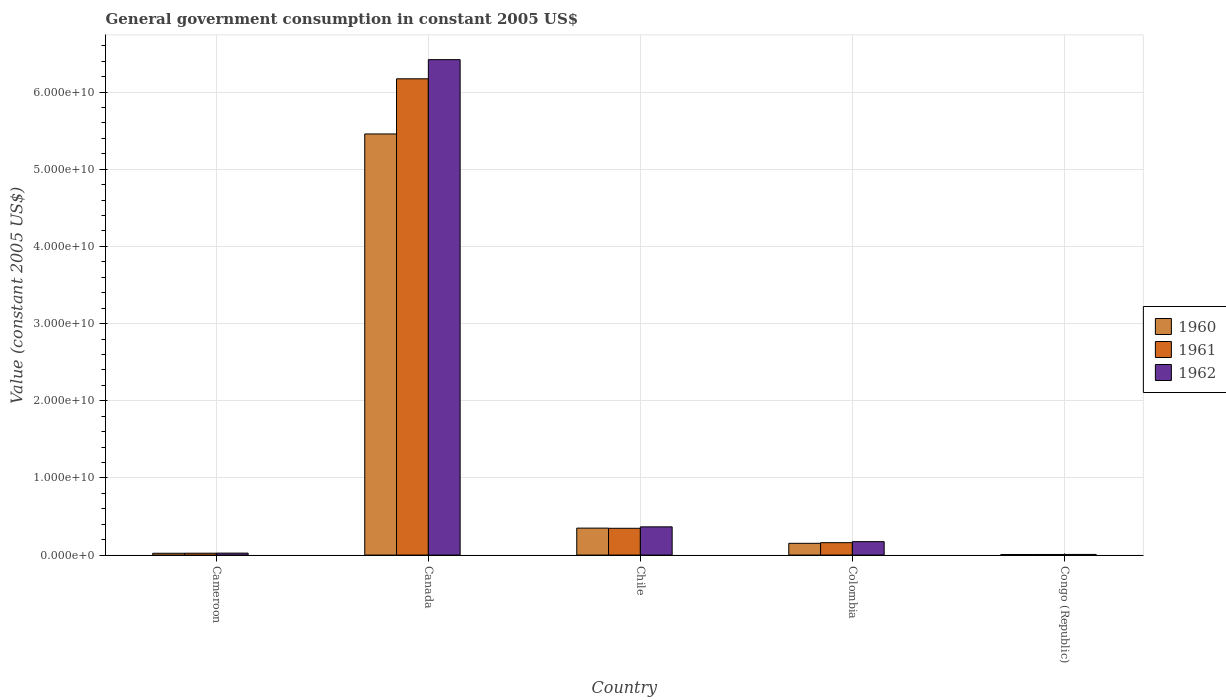How many different coloured bars are there?
Make the answer very short. 3. Are the number of bars per tick equal to the number of legend labels?
Make the answer very short. Yes. How many bars are there on the 5th tick from the left?
Your answer should be compact. 3. How many bars are there on the 5th tick from the right?
Give a very brief answer. 3. In how many cases, is the number of bars for a given country not equal to the number of legend labels?
Your response must be concise. 0. What is the government conusmption in 1960 in Congo (Republic)?
Your answer should be very brief. 7.44e+07. Across all countries, what is the maximum government conusmption in 1962?
Your response must be concise. 6.42e+1. Across all countries, what is the minimum government conusmption in 1962?
Give a very brief answer. 8.33e+07. In which country was the government conusmption in 1960 maximum?
Provide a short and direct response. Canada. In which country was the government conusmption in 1960 minimum?
Give a very brief answer. Congo (Republic). What is the total government conusmption in 1960 in the graph?
Provide a short and direct response. 5.99e+1. What is the difference between the government conusmption in 1960 in Chile and that in Congo (Republic)?
Make the answer very short. 3.42e+09. What is the difference between the government conusmption in 1962 in Cameroon and the government conusmption in 1961 in Canada?
Keep it short and to the point. -6.15e+1. What is the average government conusmption in 1960 per country?
Your answer should be compact. 1.20e+1. What is the difference between the government conusmption of/in 1961 and government conusmption of/in 1962 in Canada?
Offer a very short reply. -2.48e+09. What is the ratio of the government conusmption in 1960 in Cameroon to that in Colombia?
Offer a very short reply. 0.15. Is the difference between the government conusmption in 1961 in Canada and Congo (Republic) greater than the difference between the government conusmption in 1962 in Canada and Congo (Republic)?
Provide a short and direct response. No. What is the difference between the highest and the second highest government conusmption in 1961?
Make the answer very short. -1.86e+09. What is the difference between the highest and the lowest government conusmption in 1960?
Make the answer very short. 5.45e+1. Is the sum of the government conusmption in 1960 in Chile and Colombia greater than the maximum government conusmption in 1961 across all countries?
Ensure brevity in your answer.  No. What does the 1st bar from the left in Chile represents?
Provide a succinct answer. 1960. What does the 1st bar from the right in Congo (Republic) represents?
Provide a short and direct response. 1962. How many countries are there in the graph?
Your response must be concise. 5. What is the difference between two consecutive major ticks on the Y-axis?
Ensure brevity in your answer.  1.00e+1. Where does the legend appear in the graph?
Your response must be concise. Center right. How are the legend labels stacked?
Provide a succinct answer. Vertical. What is the title of the graph?
Offer a terse response. General government consumption in constant 2005 US$. What is the label or title of the Y-axis?
Keep it short and to the point. Value (constant 2005 US$). What is the Value (constant 2005 US$) in 1960 in Cameroon?
Provide a succinct answer. 2.33e+08. What is the Value (constant 2005 US$) in 1961 in Cameroon?
Your answer should be very brief. 2.41e+08. What is the Value (constant 2005 US$) in 1962 in Cameroon?
Give a very brief answer. 2.54e+08. What is the Value (constant 2005 US$) of 1960 in Canada?
Make the answer very short. 5.46e+1. What is the Value (constant 2005 US$) in 1961 in Canada?
Offer a very short reply. 6.17e+1. What is the Value (constant 2005 US$) in 1962 in Canada?
Your answer should be compact. 6.42e+1. What is the Value (constant 2005 US$) in 1960 in Chile?
Provide a succinct answer. 3.49e+09. What is the Value (constant 2005 US$) of 1961 in Chile?
Keep it short and to the point. 3.47e+09. What is the Value (constant 2005 US$) of 1962 in Chile?
Offer a very short reply. 3.66e+09. What is the Value (constant 2005 US$) of 1960 in Colombia?
Offer a terse response. 1.52e+09. What is the Value (constant 2005 US$) in 1961 in Colombia?
Your answer should be very brief. 1.61e+09. What is the Value (constant 2005 US$) in 1962 in Colombia?
Provide a succinct answer. 1.74e+09. What is the Value (constant 2005 US$) in 1960 in Congo (Republic)?
Offer a very short reply. 7.44e+07. What is the Value (constant 2005 US$) of 1961 in Congo (Republic)?
Your answer should be very brief. 7.67e+07. What is the Value (constant 2005 US$) in 1962 in Congo (Republic)?
Keep it short and to the point. 8.33e+07. Across all countries, what is the maximum Value (constant 2005 US$) in 1960?
Your response must be concise. 5.46e+1. Across all countries, what is the maximum Value (constant 2005 US$) in 1961?
Keep it short and to the point. 6.17e+1. Across all countries, what is the maximum Value (constant 2005 US$) of 1962?
Offer a very short reply. 6.42e+1. Across all countries, what is the minimum Value (constant 2005 US$) in 1960?
Offer a very short reply. 7.44e+07. Across all countries, what is the minimum Value (constant 2005 US$) of 1961?
Offer a very short reply. 7.67e+07. Across all countries, what is the minimum Value (constant 2005 US$) of 1962?
Make the answer very short. 8.33e+07. What is the total Value (constant 2005 US$) in 1960 in the graph?
Offer a very short reply. 5.99e+1. What is the total Value (constant 2005 US$) in 1961 in the graph?
Give a very brief answer. 6.71e+1. What is the total Value (constant 2005 US$) of 1962 in the graph?
Your answer should be very brief. 6.99e+1. What is the difference between the Value (constant 2005 US$) in 1960 in Cameroon and that in Canada?
Provide a succinct answer. -5.43e+1. What is the difference between the Value (constant 2005 US$) of 1961 in Cameroon and that in Canada?
Offer a terse response. -6.15e+1. What is the difference between the Value (constant 2005 US$) of 1962 in Cameroon and that in Canada?
Your answer should be compact. -6.40e+1. What is the difference between the Value (constant 2005 US$) in 1960 in Cameroon and that in Chile?
Offer a very short reply. -3.26e+09. What is the difference between the Value (constant 2005 US$) in 1961 in Cameroon and that in Chile?
Ensure brevity in your answer.  -3.23e+09. What is the difference between the Value (constant 2005 US$) of 1962 in Cameroon and that in Chile?
Make the answer very short. -3.40e+09. What is the difference between the Value (constant 2005 US$) in 1960 in Cameroon and that in Colombia?
Keep it short and to the point. -1.29e+09. What is the difference between the Value (constant 2005 US$) of 1961 in Cameroon and that in Colombia?
Your answer should be very brief. -1.37e+09. What is the difference between the Value (constant 2005 US$) of 1962 in Cameroon and that in Colombia?
Your response must be concise. -1.49e+09. What is the difference between the Value (constant 2005 US$) of 1960 in Cameroon and that in Congo (Republic)?
Ensure brevity in your answer.  1.59e+08. What is the difference between the Value (constant 2005 US$) in 1961 in Cameroon and that in Congo (Republic)?
Ensure brevity in your answer.  1.64e+08. What is the difference between the Value (constant 2005 US$) in 1962 in Cameroon and that in Congo (Republic)?
Your answer should be compact. 1.70e+08. What is the difference between the Value (constant 2005 US$) in 1960 in Canada and that in Chile?
Your response must be concise. 5.11e+1. What is the difference between the Value (constant 2005 US$) in 1961 in Canada and that in Chile?
Ensure brevity in your answer.  5.83e+1. What is the difference between the Value (constant 2005 US$) of 1962 in Canada and that in Chile?
Your answer should be compact. 6.05e+1. What is the difference between the Value (constant 2005 US$) in 1960 in Canada and that in Colombia?
Provide a short and direct response. 5.31e+1. What is the difference between the Value (constant 2005 US$) of 1961 in Canada and that in Colombia?
Your response must be concise. 6.01e+1. What is the difference between the Value (constant 2005 US$) in 1962 in Canada and that in Colombia?
Keep it short and to the point. 6.25e+1. What is the difference between the Value (constant 2005 US$) of 1960 in Canada and that in Congo (Republic)?
Provide a succinct answer. 5.45e+1. What is the difference between the Value (constant 2005 US$) of 1961 in Canada and that in Congo (Republic)?
Offer a terse response. 6.16e+1. What is the difference between the Value (constant 2005 US$) of 1962 in Canada and that in Congo (Republic)?
Your response must be concise. 6.41e+1. What is the difference between the Value (constant 2005 US$) in 1960 in Chile and that in Colombia?
Provide a short and direct response. 1.97e+09. What is the difference between the Value (constant 2005 US$) in 1961 in Chile and that in Colombia?
Offer a terse response. 1.86e+09. What is the difference between the Value (constant 2005 US$) of 1962 in Chile and that in Colombia?
Give a very brief answer. 1.92e+09. What is the difference between the Value (constant 2005 US$) of 1960 in Chile and that in Congo (Republic)?
Offer a terse response. 3.42e+09. What is the difference between the Value (constant 2005 US$) in 1961 in Chile and that in Congo (Republic)?
Your answer should be very brief. 3.39e+09. What is the difference between the Value (constant 2005 US$) of 1962 in Chile and that in Congo (Republic)?
Ensure brevity in your answer.  3.57e+09. What is the difference between the Value (constant 2005 US$) of 1960 in Colombia and that in Congo (Republic)?
Ensure brevity in your answer.  1.45e+09. What is the difference between the Value (constant 2005 US$) of 1961 in Colombia and that in Congo (Republic)?
Provide a succinct answer. 1.53e+09. What is the difference between the Value (constant 2005 US$) of 1962 in Colombia and that in Congo (Republic)?
Your answer should be compact. 1.66e+09. What is the difference between the Value (constant 2005 US$) in 1960 in Cameroon and the Value (constant 2005 US$) in 1961 in Canada?
Give a very brief answer. -6.15e+1. What is the difference between the Value (constant 2005 US$) in 1960 in Cameroon and the Value (constant 2005 US$) in 1962 in Canada?
Ensure brevity in your answer.  -6.40e+1. What is the difference between the Value (constant 2005 US$) in 1961 in Cameroon and the Value (constant 2005 US$) in 1962 in Canada?
Your response must be concise. -6.40e+1. What is the difference between the Value (constant 2005 US$) in 1960 in Cameroon and the Value (constant 2005 US$) in 1961 in Chile?
Provide a succinct answer. -3.24e+09. What is the difference between the Value (constant 2005 US$) of 1960 in Cameroon and the Value (constant 2005 US$) of 1962 in Chile?
Your response must be concise. -3.42e+09. What is the difference between the Value (constant 2005 US$) in 1961 in Cameroon and the Value (constant 2005 US$) in 1962 in Chile?
Make the answer very short. -3.42e+09. What is the difference between the Value (constant 2005 US$) of 1960 in Cameroon and the Value (constant 2005 US$) of 1961 in Colombia?
Ensure brevity in your answer.  -1.37e+09. What is the difference between the Value (constant 2005 US$) in 1960 in Cameroon and the Value (constant 2005 US$) in 1962 in Colombia?
Your answer should be compact. -1.51e+09. What is the difference between the Value (constant 2005 US$) of 1961 in Cameroon and the Value (constant 2005 US$) of 1962 in Colombia?
Your answer should be compact. -1.50e+09. What is the difference between the Value (constant 2005 US$) of 1960 in Cameroon and the Value (constant 2005 US$) of 1961 in Congo (Republic)?
Offer a very short reply. 1.57e+08. What is the difference between the Value (constant 2005 US$) of 1960 in Cameroon and the Value (constant 2005 US$) of 1962 in Congo (Republic)?
Make the answer very short. 1.50e+08. What is the difference between the Value (constant 2005 US$) in 1961 in Cameroon and the Value (constant 2005 US$) in 1962 in Congo (Republic)?
Keep it short and to the point. 1.58e+08. What is the difference between the Value (constant 2005 US$) in 1960 in Canada and the Value (constant 2005 US$) in 1961 in Chile?
Keep it short and to the point. 5.11e+1. What is the difference between the Value (constant 2005 US$) of 1960 in Canada and the Value (constant 2005 US$) of 1962 in Chile?
Ensure brevity in your answer.  5.09e+1. What is the difference between the Value (constant 2005 US$) in 1961 in Canada and the Value (constant 2005 US$) in 1962 in Chile?
Your answer should be very brief. 5.81e+1. What is the difference between the Value (constant 2005 US$) in 1960 in Canada and the Value (constant 2005 US$) in 1961 in Colombia?
Your answer should be compact. 5.30e+1. What is the difference between the Value (constant 2005 US$) in 1960 in Canada and the Value (constant 2005 US$) in 1962 in Colombia?
Offer a terse response. 5.28e+1. What is the difference between the Value (constant 2005 US$) of 1961 in Canada and the Value (constant 2005 US$) of 1962 in Colombia?
Your answer should be very brief. 6.00e+1. What is the difference between the Value (constant 2005 US$) of 1960 in Canada and the Value (constant 2005 US$) of 1961 in Congo (Republic)?
Make the answer very short. 5.45e+1. What is the difference between the Value (constant 2005 US$) in 1960 in Canada and the Value (constant 2005 US$) in 1962 in Congo (Republic)?
Your response must be concise. 5.45e+1. What is the difference between the Value (constant 2005 US$) in 1961 in Canada and the Value (constant 2005 US$) in 1962 in Congo (Republic)?
Offer a very short reply. 6.16e+1. What is the difference between the Value (constant 2005 US$) in 1960 in Chile and the Value (constant 2005 US$) in 1961 in Colombia?
Keep it short and to the point. 1.89e+09. What is the difference between the Value (constant 2005 US$) of 1960 in Chile and the Value (constant 2005 US$) of 1962 in Colombia?
Provide a succinct answer. 1.75e+09. What is the difference between the Value (constant 2005 US$) in 1961 in Chile and the Value (constant 2005 US$) in 1962 in Colombia?
Provide a short and direct response. 1.73e+09. What is the difference between the Value (constant 2005 US$) of 1960 in Chile and the Value (constant 2005 US$) of 1961 in Congo (Republic)?
Keep it short and to the point. 3.42e+09. What is the difference between the Value (constant 2005 US$) in 1960 in Chile and the Value (constant 2005 US$) in 1962 in Congo (Republic)?
Your answer should be compact. 3.41e+09. What is the difference between the Value (constant 2005 US$) of 1961 in Chile and the Value (constant 2005 US$) of 1962 in Congo (Republic)?
Provide a succinct answer. 3.39e+09. What is the difference between the Value (constant 2005 US$) of 1960 in Colombia and the Value (constant 2005 US$) of 1961 in Congo (Republic)?
Give a very brief answer. 1.45e+09. What is the difference between the Value (constant 2005 US$) in 1960 in Colombia and the Value (constant 2005 US$) in 1962 in Congo (Republic)?
Provide a short and direct response. 1.44e+09. What is the difference between the Value (constant 2005 US$) in 1961 in Colombia and the Value (constant 2005 US$) in 1962 in Congo (Republic)?
Give a very brief answer. 1.52e+09. What is the average Value (constant 2005 US$) in 1960 per country?
Your answer should be compact. 1.20e+1. What is the average Value (constant 2005 US$) in 1961 per country?
Keep it short and to the point. 1.34e+1. What is the average Value (constant 2005 US$) in 1962 per country?
Make the answer very short. 1.40e+1. What is the difference between the Value (constant 2005 US$) in 1960 and Value (constant 2005 US$) in 1961 in Cameroon?
Keep it short and to the point. -7.57e+06. What is the difference between the Value (constant 2005 US$) in 1960 and Value (constant 2005 US$) in 1962 in Cameroon?
Make the answer very short. -2.04e+07. What is the difference between the Value (constant 2005 US$) in 1961 and Value (constant 2005 US$) in 1962 in Cameroon?
Offer a terse response. -1.29e+07. What is the difference between the Value (constant 2005 US$) of 1960 and Value (constant 2005 US$) of 1961 in Canada?
Provide a succinct answer. -7.15e+09. What is the difference between the Value (constant 2005 US$) of 1960 and Value (constant 2005 US$) of 1962 in Canada?
Offer a very short reply. -9.63e+09. What is the difference between the Value (constant 2005 US$) in 1961 and Value (constant 2005 US$) in 1962 in Canada?
Keep it short and to the point. -2.48e+09. What is the difference between the Value (constant 2005 US$) in 1960 and Value (constant 2005 US$) in 1961 in Chile?
Provide a succinct answer. 2.27e+07. What is the difference between the Value (constant 2005 US$) of 1960 and Value (constant 2005 US$) of 1962 in Chile?
Make the answer very short. -1.64e+08. What is the difference between the Value (constant 2005 US$) in 1961 and Value (constant 2005 US$) in 1962 in Chile?
Keep it short and to the point. -1.87e+08. What is the difference between the Value (constant 2005 US$) of 1960 and Value (constant 2005 US$) of 1961 in Colombia?
Offer a terse response. -8.37e+07. What is the difference between the Value (constant 2005 US$) of 1960 and Value (constant 2005 US$) of 1962 in Colombia?
Give a very brief answer. -2.18e+08. What is the difference between the Value (constant 2005 US$) in 1961 and Value (constant 2005 US$) in 1962 in Colombia?
Your answer should be compact. -1.34e+08. What is the difference between the Value (constant 2005 US$) of 1960 and Value (constant 2005 US$) of 1961 in Congo (Republic)?
Make the answer very short. -2.22e+06. What is the difference between the Value (constant 2005 US$) in 1960 and Value (constant 2005 US$) in 1962 in Congo (Republic)?
Your answer should be compact. -8.89e+06. What is the difference between the Value (constant 2005 US$) in 1961 and Value (constant 2005 US$) in 1962 in Congo (Republic)?
Make the answer very short. -6.67e+06. What is the ratio of the Value (constant 2005 US$) of 1960 in Cameroon to that in Canada?
Make the answer very short. 0. What is the ratio of the Value (constant 2005 US$) of 1961 in Cameroon to that in Canada?
Give a very brief answer. 0. What is the ratio of the Value (constant 2005 US$) of 1962 in Cameroon to that in Canada?
Offer a terse response. 0. What is the ratio of the Value (constant 2005 US$) in 1960 in Cameroon to that in Chile?
Your answer should be very brief. 0.07. What is the ratio of the Value (constant 2005 US$) of 1961 in Cameroon to that in Chile?
Your answer should be very brief. 0.07. What is the ratio of the Value (constant 2005 US$) in 1962 in Cameroon to that in Chile?
Offer a very short reply. 0.07. What is the ratio of the Value (constant 2005 US$) of 1960 in Cameroon to that in Colombia?
Ensure brevity in your answer.  0.15. What is the ratio of the Value (constant 2005 US$) of 1961 in Cameroon to that in Colombia?
Make the answer very short. 0.15. What is the ratio of the Value (constant 2005 US$) in 1962 in Cameroon to that in Colombia?
Ensure brevity in your answer.  0.15. What is the ratio of the Value (constant 2005 US$) in 1960 in Cameroon to that in Congo (Republic)?
Make the answer very short. 3.13. What is the ratio of the Value (constant 2005 US$) in 1961 in Cameroon to that in Congo (Republic)?
Give a very brief answer. 3.14. What is the ratio of the Value (constant 2005 US$) of 1962 in Cameroon to that in Congo (Republic)?
Provide a short and direct response. 3.05. What is the ratio of the Value (constant 2005 US$) of 1960 in Canada to that in Chile?
Offer a terse response. 15.62. What is the ratio of the Value (constant 2005 US$) in 1961 in Canada to that in Chile?
Provide a short and direct response. 17.78. What is the ratio of the Value (constant 2005 US$) in 1962 in Canada to that in Chile?
Your response must be concise. 17.55. What is the ratio of the Value (constant 2005 US$) in 1960 in Canada to that in Colombia?
Your answer should be very brief. 35.84. What is the ratio of the Value (constant 2005 US$) in 1961 in Canada to that in Colombia?
Offer a very short reply. 38.42. What is the ratio of the Value (constant 2005 US$) of 1962 in Canada to that in Colombia?
Provide a succinct answer. 36.89. What is the ratio of the Value (constant 2005 US$) in 1960 in Canada to that in Congo (Republic)?
Ensure brevity in your answer.  733.2. What is the ratio of the Value (constant 2005 US$) of 1961 in Canada to that in Congo (Republic)?
Provide a succinct answer. 805.21. What is the ratio of the Value (constant 2005 US$) in 1962 in Canada to that in Congo (Republic)?
Your answer should be compact. 770.58. What is the ratio of the Value (constant 2005 US$) of 1960 in Chile to that in Colombia?
Offer a very short reply. 2.29. What is the ratio of the Value (constant 2005 US$) of 1961 in Chile to that in Colombia?
Provide a succinct answer. 2.16. What is the ratio of the Value (constant 2005 US$) of 1962 in Chile to that in Colombia?
Provide a short and direct response. 2.1. What is the ratio of the Value (constant 2005 US$) of 1960 in Chile to that in Congo (Republic)?
Offer a terse response. 46.93. What is the ratio of the Value (constant 2005 US$) of 1961 in Chile to that in Congo (Republic)?
Give a very brief answer. 45.28. What is the ratio of the Value (constant 2005 US$) in 1962 in Chile to that in Congo (Republic)?
Your response must be concise. 43.9. What is the ratio of the Value (constant 2005 US$) in 1960 in Colombia to that in Congo (Republic)?
Offer a terse response. 20.46. What is the ratio of the Value (constant 2005 US$) in 1961 in Colombia to that in Congo (Republic)?
Ensure brevity in your answer.  20.96. What is the ratio of the Value (constant 2005 US$) in 1962 in Colombia to that in Congo (Republic)?
Your response must be concise. 20.89. What is the difference between the highest and the second highest Value (constant 2005 US$) of 1960?
Your response must be concise. 5.11e+1. What is the difference between the highest and the second highest Value (constant 2005 US$) in 1961?
Your answer should be very brief. 5.83e+1. What is the difference between the highest and the second highest Value (constant 2005 US$) in 1962?
Provide a short and direct response. 6.05e+1. What is the difference between the highest and the lowest Value (constant 2005 US$) in 1960?
Provide a short and direct response. 5.45e+1. What is the difference between the highest and the lowest Value (constant 2005 US$) in 1961?
Your answer should be compact. 6.16e+1. What is the difference between the highest and the lowest Value (constant 2005 US$) in 1962?
Provide a succinct answer. 6.41e+1. 